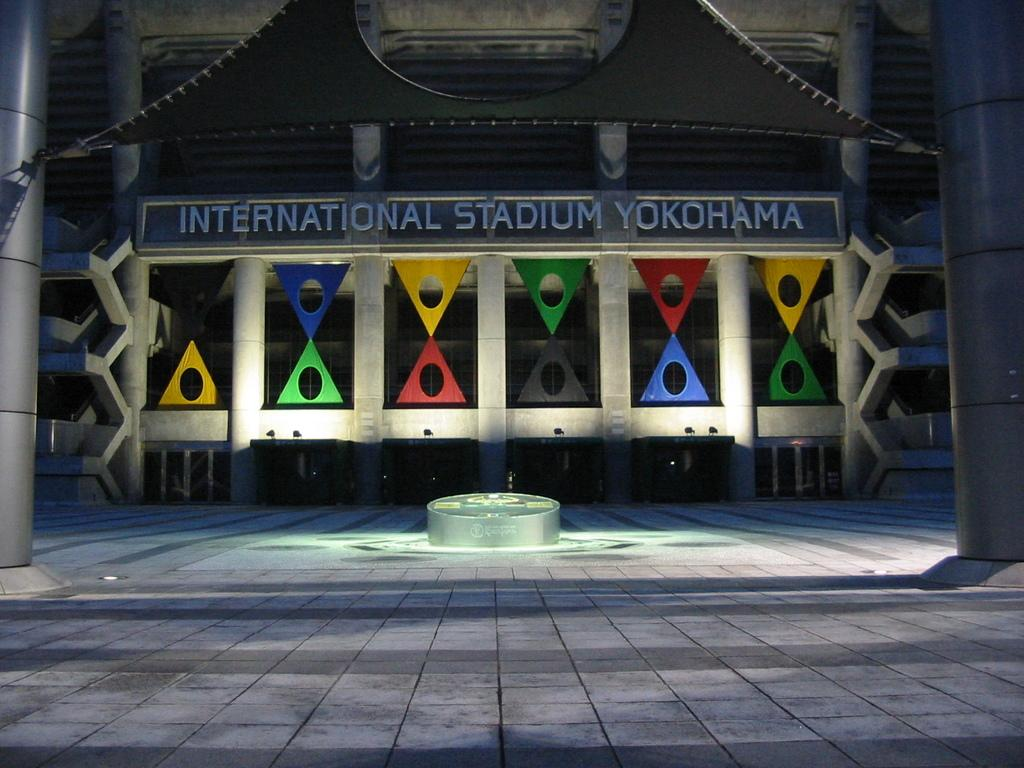What type of structure is the main subject of the image? There is a stadium in the image. What else can be seen in the image besides the stadium? There is a big wall with text in the image. How is the stadium decorated? The stadium is decorated with colorful triangles. What other objects are present in the image? There are two poles in the image. How many lizards are crawling on the big wall in the image? There are no lizards present in the image; the big wall has text on it. Can you describe the men standing near the poles in the image? There are no men present in the image; only the stadium, big wall, text, colorful triangles, and two poles can be seen. 